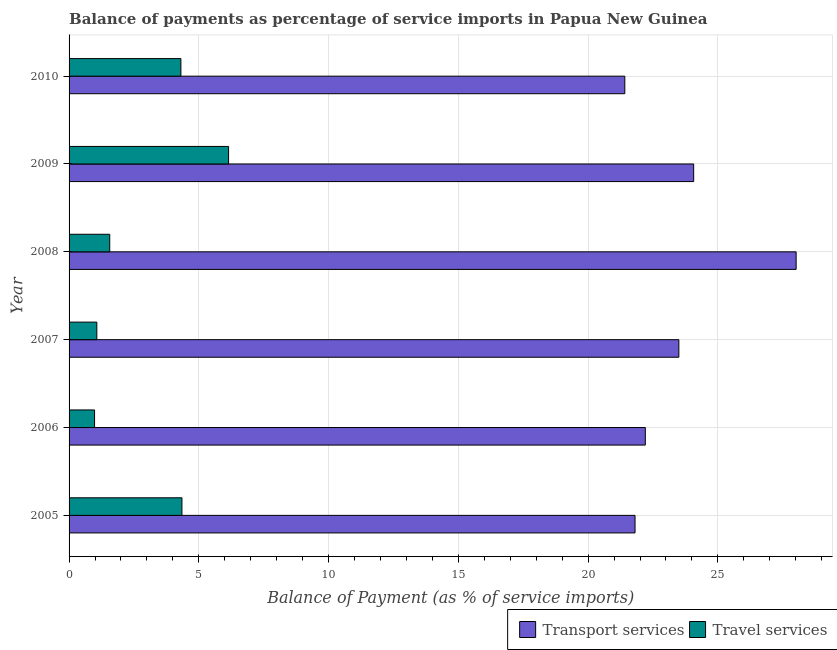Are the number of bars per tick equal to the number of legend labels?
Offer a very short reply. Yes. Are the number of bars on each tick of the Y-axis equal?
Your answer should be very brief. Yes. How many bars are there on the 2nd tick from the top?
Offer a very short reply. 2. How many bars are there on the 4th tick from the bottom?
Provide a short and direct response. 2. What is the label of the 1st group of bars from the top?
Your answer should be compact. 2010. In how many cases, is the number of bars for a given year not equal to the number of legend labels?
Make the answer very short. 0. What is the balance of payments of transport services in 2010?
Provide a succinct answer. 21.41. Across all years, what is the maximum balance of payments of travel services?
Your answer should be compact. 6.15. Across all years, what is the minimum balance of payments of travel services?
Ensure brevity in your answer.  0.98. In which year was the balance of payments of travel services maximum?
Make the answer very short. 2009. In which year was the balance of payments of transport services minimum?
Make the answer very short. 2010. What is the total balance of payments of transport services in the graph?
Your answer should be compact. 141.01. What is the difference between the balance of payments of transport services in 2006 and that in 2007?
Ensure brevity in your answer.  -1.29. What is the difference between the balance of payments of travel services in 2005 and the balance of payments of transport services in 2006?
Keep it short and to the point. -17.86. What is the average balance of payments of transport services per year?
Provide a short and direct response. 23.5. In the year 2008, what is the difference between the balance of payments of transport services and balance of payments of travel services?
Your answer should be compact. 26.45. In how many years, is the balance of payments of transport services greater than 14 %?
Make the answer very short. 6. What is the ratio of the balance of payments of travel services in 2009 to that in 2010?
Ensure brevity in your answer.  1.43. Is the difference between the balance of payments of travel services in 2005 and 2008 greater than the difference between the balance of payments of transport services in 2005 and 2008?
Your answer should be very brief. Yes. What is the difference between the highest and the second highest balance of payments of travel services?
Keep it short and to the point. 1.8. What does the 1st bar from the top in 2005 represents?
Keep it short and to the point. Travel services. What does the 2nd bar from the bottom in 2009 represents?
Keep it short and to the point. Travel services. How many bars are there?
Offer a terse response. 12. Are all the bars in the graph horizontal?
Ensure brevity in your answer.  Yes. Are the values on the major ticks of X-axis written in scientific E-notation?
Your response must be concise. No. Does the graph contain any zero values?
Make the answer very short. No. Does the graph contain grids?
Make the answer very short. Yes. Where does the legend appear in the graph?
Provide a succinct answer. Bottom right. How many legend labels are there?
Give a very brief answer. 2. How are the legend labels stacked?
Provide a succinct answer. Horizontal. What is the title of the graph?
Keep it short and to the point. Balance of payments as percentage of service imports in Papua New Guinea. Does "Broad money growth" appear as one of the legend labels in the graph?
Give a very brief answer. No. What is the label or title of the X-axis?
Offer a terse response. Balance of Payment (as % of service imports). What is the label or title of the Y-axis?
Give a very brief answer. Year. What is the Balance of Payment (as % of service imports) in Transport services in 2005?
Provide a succinct answer. 21.81. What is the Balance of Payment (as % of service imports) in Travel services in 2005?
Make the answer very short. 4.35. What is the Balance of Payment (as % of service imports) in Transport services in 2006?
Provide a short and direct response. 22.2. What is the Balance of Payment (as % of service imports) in Travel services in 2006?
Offer a very short reply. 0.98. What is the Balance of Payment (as % of service imports) in Transport services in 2007?
Ensure brevity in your answer.  23.5. What is the Balance of Payment (as % of service imports) in Travel services in 2007?
Ensure brevity in your answer.  1.07. What is the Balance of Payment (as % of service imports) in Transport services in 2008?
Your response must be concise. 28.02. What is the Balance of Payment (as % of service imports) of Travel services in 2008?
Make the answer very short. 1.57. What is the Balance of Payment (as % of service imports) of Transport services in 2009?
Provide a succinct answer. 24.07. What is the Balance of Payment (as % of service imports) of Travel services in 2009?
Provide a short and direct response. 6.15. What is the Balance of Payment (as % of service imports) in Transport services in 2010?
Your response must be concise. 21.41. What is the Balance of Payment (as % of service imports) in Travel services in 2010?
Make the answer very short. 4.31. Across all years, what is the maximum Balance of Payment (as % of service imports) in Transport services?
Ensure brevity in your answer.  28.02. Across all years, what is the maximum Balance of Payment (as % of service imports) of Travel services?
Your answer should be compact. 6.15. Across all years, what is the minimum Balance of Payment (as % of service imports) in Transport services?
Offer a very short reply. 21.41. Across all years, what is the minimum Balance of Payment (as % of service imports) of Travel services?
Keep it short and to the point. 0.98. What is the total Balance of Payment (as % of service imports) of Transport services in the graph?
Provide a short and direct response. 141.01. What is the total Balance of Payment (as % of service imports) in Travel services in the graph?
Your answer should be compact. 18.42. What is the difference between the Balance of Payment (as % of service imports) of Transport services in 2005 and that in 2006?
Your response must be concise. -0.4. What is the difference between the Balance of Payment (as % of service imports) of Travel services in 2005 and that in 2006?
Your answer should be very brief. 3.37. What is the difference between the Balance of Payment (as % of service imports) in Transport services in 2005 and that in 2007?
Provide a short and direct response. -1.69. What is the difference between the Balance of Payment (as % of service imports) in Travel services in 2005 and that in 2007?
Your answer should be very brief. 3.28. What is the difference between the Balance of Payment (as % of service imports) of Transport services in 2005 and that in 2008?
Your answer should be very brief. -6.21. What is the difference between the Balance of Payment (as % of service imports) in Travel services in 2005 and that in 2008?
Make the answer very short. 2.78. What is the difference between the Balance of Payment (as % of service imports) of Transport services in 2005 and that in 2009?
Make the answer very short. -2.26. What is the difference between the Balance of Payment (as % of service imports) in Travel services in 2005 and that in 2009?
Offer a terse response. -1.8. What is the difference between the Balance of Payment (as % of service imports) of Transport services in 2005 and that in 2010?
Keep it short and to the point. 0.39. What is the difference between the Balance of Payment (as % of service imports) of Travel services in 2005 and that in 2010?
Your response must be concise. 0.04. What is the difference between the Balance of Payment (as % of service imports) of Transport services in 2006 and that in 2007?
Give a very brief answer. -1.29. What is the difference between the Balance of Payment (as % of service imports) in Travel services in 2006 and that in 2007?
Give a very brief answer. -0.09. What is the difference between the Balance of Payment (as % of service imports) in Transport services in 2006 and that in 2008?
Ensure brevity in your answer.  -5.81. What is the difference between the Balance of Payment (as % of service imports) of Travel services in 2006 and that in 2008?
Provide a short and direct response. -0.59. What is the difference between the Balance of Payment (as % of service imports) of Transport services in 2006 and that in 2009?
Offer a very short reply. -1.86. What is the difference between the Balance of Payment (as % of service imports) in Travel services in 2006 and that in 2009?
Ensure brevity in your answer.  -5.16. What is the difference between the Balance of Payment (as % of service imports) of Transport services in 2006 and that in 2010?
Provide a short and direct response. 0.79. What is the difference between the Balance of Payment (as % of service imports) of Travel services in 2006 and that in 2010?
Make the answer very short. -3.33. What is the difference between the Balance of Payment (as % of service imports) in Transport services in 2007 and that in 2008?
Offer a terse response. -4.52. What is the difference between the Balance of Payment (as % of service imports) in Travel services in 2007 and that in 2008?
Ensure brevity in your answer.  -0.5. What is the difference between the Balance of Payment (as % of service imports) of Transport services in 2007 and that in 2009?
Make the answer very short. -0.57. What is the difference between the Balance of Payment (as % of service imports) of Travel services in 2007 and that in 2009?
Offer a very short reply. -5.08. What is the difference between the Balance of Payment (as % of service imports) of Transport services in 2007 and that in 2010?
Keep it short and to the point. 2.08. What is the difference between the Balance of Payment (as % of service imports) of Travel services in 2007 and that in 2010?
Make the answer very short. -3.24. What is the difference between the Balance of Payment (as % of service imports) in Transport services in 2008 and that in 2009?
Keep it short and to the point. 3.95. What is the difference between the Balance of Payment (as % of service imports) in Travel services in 2008 and that in 2009?
Ensure brevity in your answer.  -4.58. What is the difference between the Balance of Payment (as % of service imports) of Transport services in 2008 and that in 2010?
Give a very brief answer. 6.6. What is the difference between the Balance of Payment (as % of service imports) in Travel services in 2008 and that in 2010?
Ensure brevity in your answer.  -2.74. What is the difference between the Balance of Payment (as % of service imports) in Transport services in 2009 and that in 2010?
Provide a succinct answer. 2.65. What is the difference between the Balance of Payment (as % of service imports) in Travel services in 2009 and that in 2010?
Your answer should be very brief. 1.84. What is the difference between the Balance of Payment (as % of service imports) in Transport services in 2005 and the Balance of Payment (as % of service imports) in Travel services in 2006?
Make the answer very short. 20.83. What is the difference between the Balance of Payment (as % of service imports) in Transport services in 2005 and the Balance of Payment (as % of service imports) in Travel services in 2007?
Offer a terse response. 20.74. What is the difference between the Balance of Payment (as % of service imports) in Transport services in 2005 and the Balance of Payment (as % of service imports) in Travel services in 2008?
Your response must be concise. 20.24. What is the difference between the Balance of Payment (as % of service imports) of Transport services in 2005 and the Balance of Payment (as % of service imports) of Travel services in 2009?
Offer a very short reply. 15.66. What is the difference between the Balance of Payment (as % of service imports) in Transport services in 2005 and the Balance of Payment (as % of service imports) in Travel services in 2010?
Make the answer very short. 17.5. What is the difference between the Balance of Payment (as % of service imports) in Transport services in 2006 and the Balance of Payment (as % of service imports) in Travel services in 2007?
Give a very brief answer. 21.14. What is the difference between the Balance of Payment (as % of service imports) of Transport services in 2006 and the Balance of Payment (as % of service imports) of Travel services in 2008?
Ensure brevity in your answer.  20.64. What is the difference between the Balance of Payment (as % of service imports) in Transport services in 2006 and the Balance of Payment (as % of service imports) in Travel services in 2009?
Give a very brief answer. 16.06. What is the difference between the Balance of Payment (as % of service imports) in Transport services in 2006 and the Balance of Payment (as % of service imports) in Travel services in 2010?
Your answer should be very brief. 17.9. What is the difference between the Balance of Payment (as % of service imports) of Transport services in 2007 and the Balance of Payment (as % of service imports) of Travel services in 2008?
Your answer should be compact. 21.93. What is the difference between the Balance of Payment (as % of service imports) in Transport services in 2007 and the Balance of Payment (as % of service imports) in Travel services in 2009?
Give a very brief answer. 17.35. What is the difference between the Balance of Payment (as % of service imports) of Transport services in 2007 and the Balance of Payment (as % of service imports) of Travel services in 2010?
Your response must be concise. 19.19. What is the difference between the Balance of Payment (as % of service imports) in Transport services in 2008 and the Balance of Payment (as % of service imports) in Travel services in 2009?
Your answer should be compact. 21.87. What is the difference between the Balance of Payment (as % of service imports) in Transport services in 2008 and the Balance of Payment (as % of service imports) in Travel services in 2010?
Offer a terse response. 23.71. What is the difference between the Balance of Payment (as % of service imports) of Transport services in 2009 and the Balance of Payment (as % of service imports) of Travel services in 2010?
Offer a terse response. 19.76. What is the average Balance of Payment (as % of service imports) in Transport services per year?
Give a very brief answer. 23.5. What is the average Balance of Payment (as % of service imports) in Travel services per year?
Offer a terse response. 3.07. In the year 2005, what is the difference between the Balance of Payment (as % of service imports) in Transport services and Balance of Payment (as % of service imports) in Travel services?
Ensure brevity in your answer.  17.46. In the year 2006, what is the difference between the Balance of Payment (as % of service imports) in Transport services and Balance of Payment (as % of service imports) in Travel services?
Your answer should be compact. 21.22. In the year 2007, what is the difference between the Balance of Payment (as % of service imports) in Transport services and Balance of Payment (as % of service imports) in Travel services?
Keep it short and to the point. 22.43. In the year 2008, what is the difference between the Balance of Payment (as % of service imports) of Transport services and Balance of Payment (as % of service imports) of Travel services?
Ensure brevity in your answer.  26.45. In the year 2009, what is the difference between the Balance of Payment (as % of service imports) of Transport services and Balance of Payment (as % of service imports) of Travel services?
Give a very brief answer. 17.92. In the year 2010, what is the difference between the Balance of Payment (as % of service imports) in Transport services and Balance of Payment (as % of service imports) in Travel services?
Provide a short and direct response. 17.11. What is the ratio of the Balance of Payment (as % of service imports) of Transport services in 2005 to that in 2006?
Provide a succinct answer. 0.98. What is the ratio of the Balance of Payment (as % of service imports) in Travel services in 2005 to that in 2006?
Your response must be concise. 4.43. What is the ratio of the Balance of Payment (as % of service imports) of Transport services in 2005 to that in 2007?
Make the answer very short. 0.93. What is the ratio of the Balance of Payment (as % of service imports) in Travel services in 2005 to that in 2007?
Offer a very short reply. 4.07. What is the ratio of the Balance of Payment (as % of service imports) of Transport services in 2005 to that in 2008?
Ensure brevity in your answer.  0.78. What is the ratio of the Balance of Payment (as % of service imports) in Travel services in 2005 to that in 2008?
Ensure brevity in your answer.  2.78. What is the ratio of the Balance of Payment (as % of service imports) in Transport services in 2005 to that in 2009?
Keep it short and to the point. 0.91. What is the ratio of the Balance of Payment (as % of service imports) in Travel services in 2005 to that in 2009?
Provide a short and direct response. 0.71. What is the ratio of the Balance of Payment (as % of service imports) in Transport services in 2005 to that in 2010?
Your response must be concise. 1.02. What is the ratio of the Balance of Payment (as % of service imports) of Travel services in 2005 to that in 2010?
Give a very brief answer. 1.01. What is the ratio of the Balance of Payment (as % of service imports) of Transport services in 2006 to that in 2007?
Your answer should be very brief. 0.94. What is the ratio of the Balance of Payment (as % of service imports) in Travel services in 2006 to that in 2007?
Your answer should be compact. 0.92. What is the ratio of the Balance of Payment (as % of service imports) in Transport services in 2006 to that in 2008?
Keep it short and to the point. 0.79. What is the ratio of the Balance of Payment (as % of service imports) in Travel services in 2006 to that in 2008?
Your response must be concise. 0.63. What is the ratio of the Balance of Payment (as % of service imports) in Transport services in 2006 to that in 2009?
Provide a succinct answer. 0.92. What is the ratio of the Balance of Payment (as % of service imports) of Travel services in 2006 to that in 2009?
Your answer should be compact. 0.16. What is the ratio of the Balance of Payment (as % of service imports) of Transport services in 2006 to that in 2010?
Your response must be concise. 1.04. What is the ratio of the Balance of Payment (as % of service imports) of Travel services in 2006 to that in 2010?
Provide a short and direct response. 0.23. What is the ratio of the Balance of Payment (as % of service imports) in Transport services in 2007 to that in 2008?
Provide a succinct answer. 0.84. What is the ratio of the Balance of Payment (as % of service imports) in Travel services in 2007 to that in 2008?
Keep it short and to the point. 0.68. What is the ratio of the Balance of Payment (as % of service imports) in Transport services in 2007 to that in 2009?
Ensure brevity in your answer.  0.98. What is the ratio of the Balance of Payment (as % of service imports) of Travel services in 2007 to that in 2009?
Offer a terse response. 0.17. What is the ratio of the Balance of Payment (as % of service imports) of Transport services in 2007 to that in 2010?
Keep it short and to the point. 1.1. What is the ratio of the Balance of Payment (as % of service imports) of Travel services in 2007 to that in 2010?
Keep it short and to the point. 0.25. What is the ratio of the Balance of Payment (as % of service imports) of Transport services in 2008 to that in 2009?
Your response must be concise. 1.16. What is the ratio of the Balance of Payment (as % of service imports) of Travel services in 2008 to that in 2009?
Offer a very short reply. 0.25. What is the ratio of the Balance of Payment (as % of service imports) in Transport services in 2008 to that in 2010?
Ensure brevity in your answer.  1.31. What is the ratio of the Balance of Payment (as % of service imports) of Travel services in 2008 to that in 2010?
Give a very brief answer. 0.36. What is the ratio of the Balance of Payment (as % of service imports) in Transport services in 2009 to that in 2010?
Give a very brief answer. 1.12. What is the ratio of the Balance of Payment (as % of service imports) in Travel services in 2009 to that in 2010?
Ensure brevity in your answer.  1.43. What is the difference between the highest and the second highest Balance of Payment (as % of service imports) of Transport services?
Offer a very short reply. 3.95. What is the difference between the highest and the second highest Balance of Payment (as % of service imports) in Travel services?
Provide a succinct answer. 1.8. What is the difference between the highest and the lowest Balance of Payment (as % of service imports) in Transport services?
Your answer should be compact. 6.6. What is the difference between the highest and the lowest Balance of Payment (as % of service imports) of Travel services?
Your answer should be compact. 5.16. 